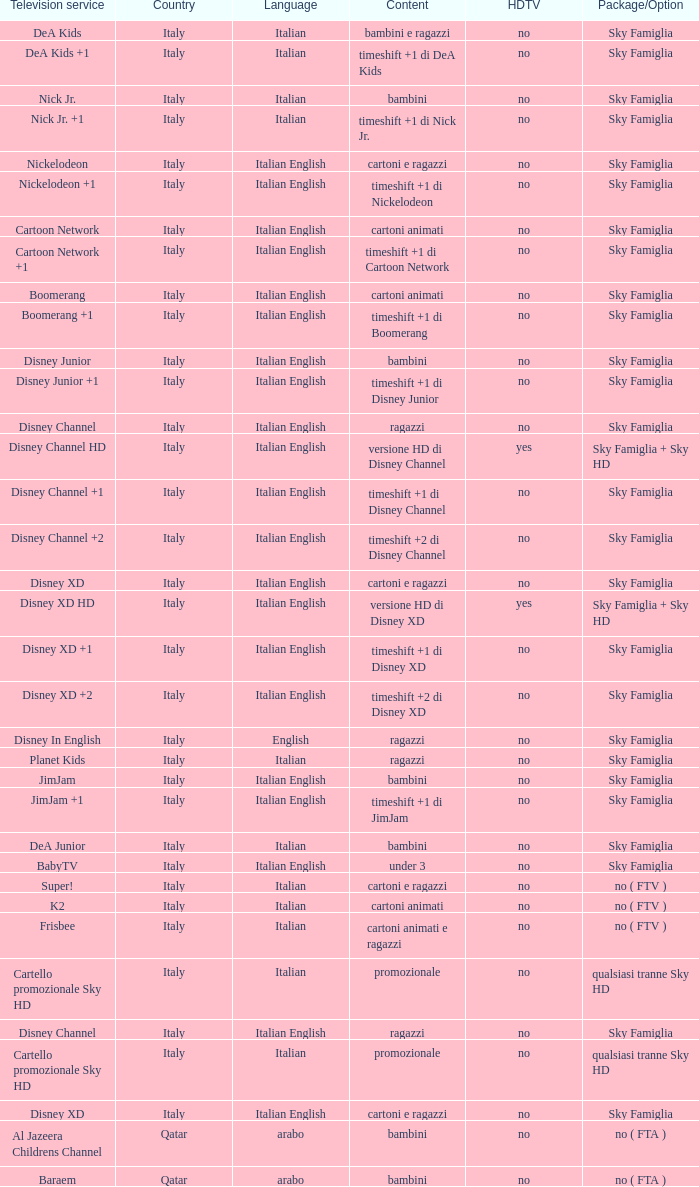What programs can be found on the nickelodeon +1 tv channel? Timeshift +1 di nickelodeon. 